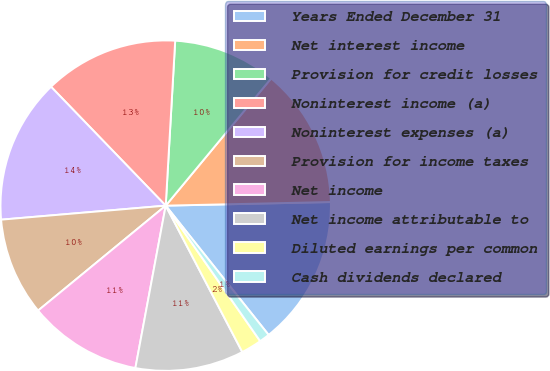Convert chart. <chart><loc_0><loc_0><loc_500><loc_500><pie_chart><fcel>Years Ended December 31<fcel>Net interest income<fcel>Provision for credit losses<fcel>Noninterest income (a)<fcel>Noninterest expenses (a)<fcel>Provision for income taxes<fcel>Net income<fcel>Net income attributable to<fcel>Diluted earnings per common<fcel>Cash dividends declared<nl><fcel>14.65%<fcel>13.64%<fcel>10.1%<fcel>13.13%<fcel>14.14%<fcel>9.6%<fcel>11.11%<fcel>10.61%<fcel>2.02%<fcel>1.01%<nl></chart> 